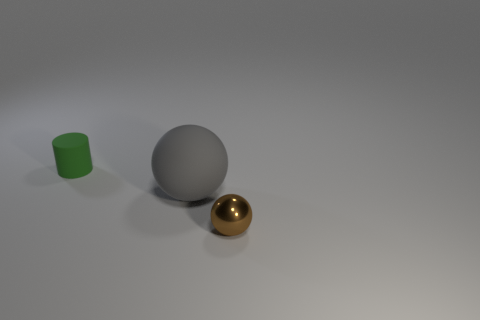What color is the object that is behind the small ball and in front of the green rubber thing?
Ensure brevity in your answer.  Gray. Is there a cylinder of the same color as the large thing?
Make the answer very short. No. What is the color of the tiny object that is behind the gray rubber object?
Offer a very short reply. Green. There is a object that is to the right of the gray matte sphere; are there any green matte cylinders behind it?
Your answer should be very brief. Yes. There is a tiny ball; is its color the same as the sphere behind the brown shiny sphere?
Keep it short and to the point. No. Are there any big cyan cubes that have the same material as the gray ball?
Your answer should be compact. No. How many green rubber things are there?
Your response must be concise. 1. What material is the sphere that is behind the small thing that is in front of the gray sphere made of?
Ensure brevity in your answer.  Rubber. What is the color of the tiny cylinder that is made of the same material as the large gray sphere?
Offer a very short reply. Green. Is the size of the rubber thing to the right of the small green rubber object the same as the matte object left of the gray ball?
Offer a very short reply. No. 